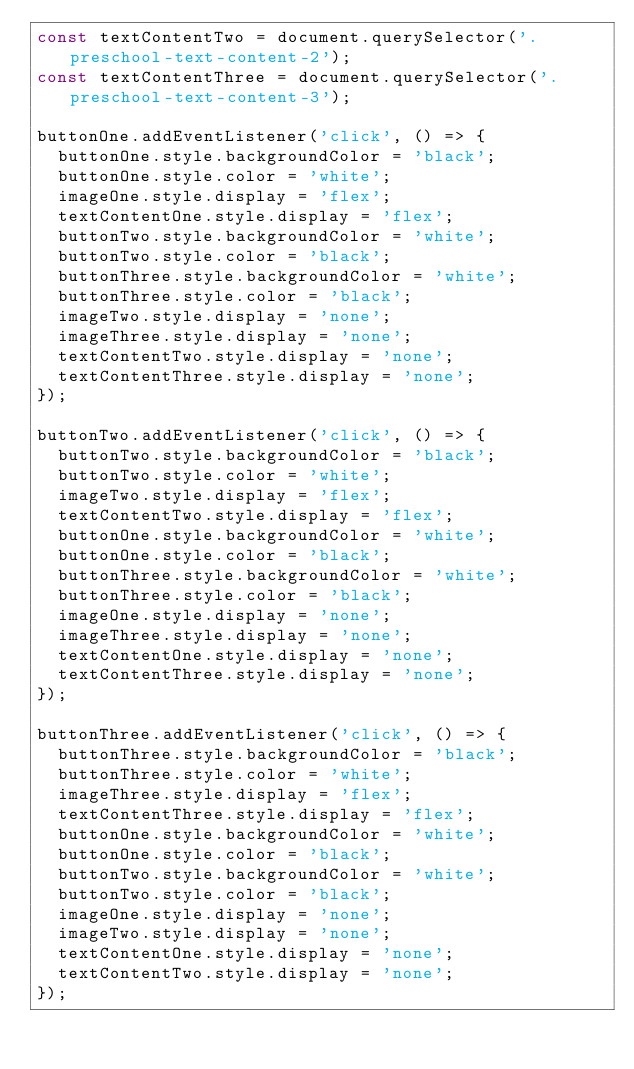Convert code to text. <code><loc_0><loc_0><loc_500><loc_500><_JavaScript_>const textContentTwo = document.querySelector('.preschool-text-content-2');
const textContentThree = document.querySelector('.preschool-text-content-3');

buttonOne.addEventListener('click', () => {
  buttonOne.style.backgroundColor = 'black';
  buttonOne.style.color = 'white';
  imageOne.style.display = 'flex';
  textContentOne.style.display = 'flex';
  buttonTwo.style.backgroundColor = 'white';
  buttonTwo.style.color = 'black';
  buttonThree.style.backgroundColor = 'white';
  buttonThree.style.color = 'black';
  imageTwo.style.display = 'none';
  imageThree.style.display = 'none';
  textContentTwo.style.display = 'none';
  textContentThree.style.display = 'none';
});

buttonTwo.addEventListener('click', () => {
  buttonTwo.style.backgroundColor = 'black';
  buttonTwo.style.color = 'white';
  imageTwo.style.display = 'flex';
  textContentTwo.style.display = 'flex';
  buttonOne.style.backgroundColor = 'white';
  buttonOne.style.color = 'black';
  buttonThree.style.backgroundColor = 'white';
  buttonThree.style.color = 'black';
  imageOne.style.display = 'none';
  imageThree.style.display = 'none';
  textContentOne.style.display = 'none';
  textContentThree.style.display = 'none';
});

buttonThree.addEventListener('click', () => {
  buttonThree.style.backgroundColor = 'black';
  buttonThree.style.color = 'white';
  imageThree.style.display = 'flex';
  textContentThree.style.display = 'flex';
  buttonOne.style.backgroundColor = 'white';
  buttonOne.style.color = 'black';
  buttonTwo.style.backgroundColor = 'white';
  buttonTwo.style.color = 'black';
  imageOne.style.display = 'none';
  imageTwo.style.display = 'none';
  textContentOne.style.display = 'none';
  textContentTwo.style.display = 'none';
});
</code> 